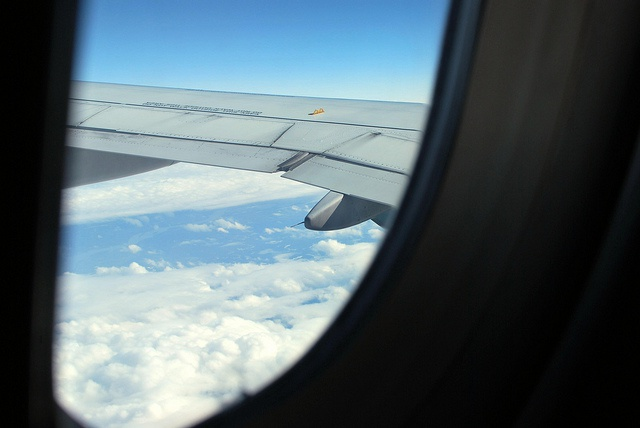Describe the objects in this image and their specific colors. I can see a airplane in black, lightblue, darkgray, and gray tones in this image. 